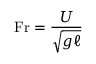<formula> <loc_0><loc_0><loc_500><loc_500>F r = { \frac { U } { \sqrt { g \ell } } }</formula> 